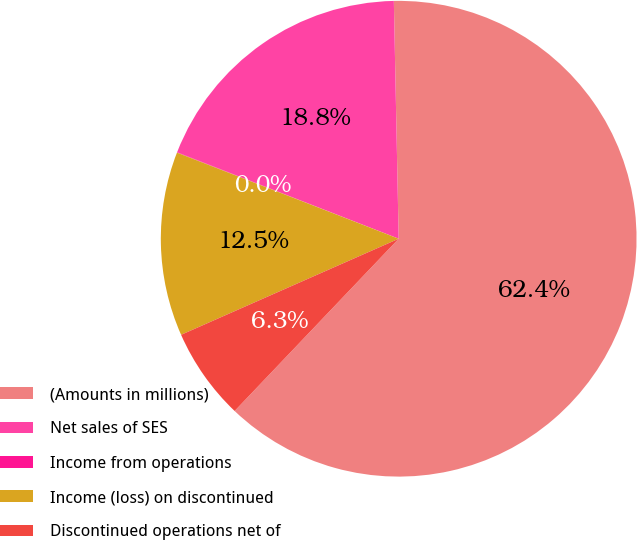<chart> <loc_0><loc_0><loc_500><loc_500><pie_chart><fcel>(Amounts in millions)<fcel>Net sales of SES<fcel>Income from operations<fcel>Income (loss) on discontinued<fcel>Discontinued operations net of<nl><fcel>62.43%<fcel>18.75%<fcel>0.03%<fcel>12.51%<fcel>6.27%<nl></chart> 